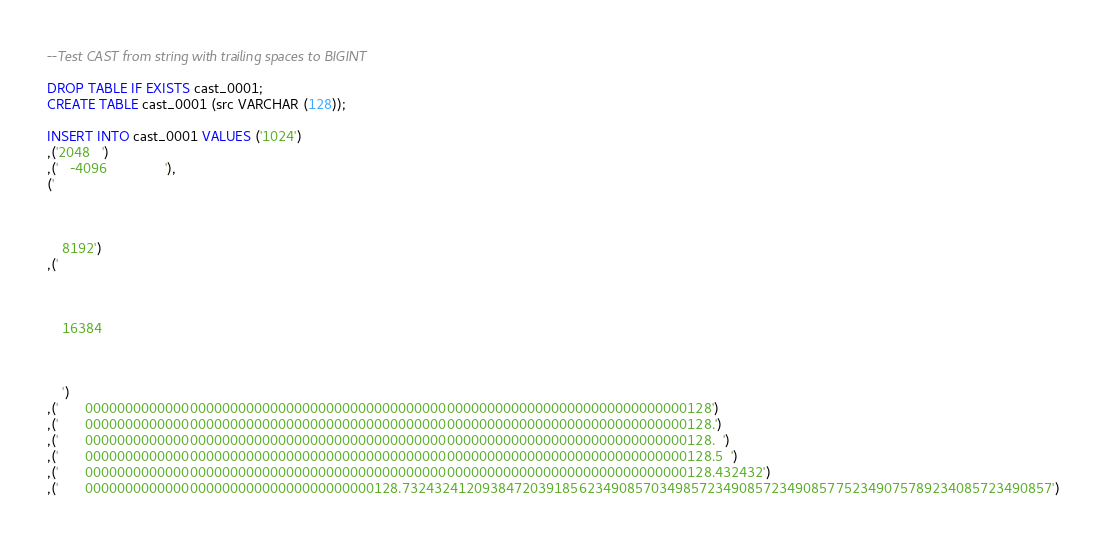Convert code to text. <code><loc_0><loc_0><loc_500><loc_500><_SQL_>--Test CAST from string with trailing spaces to BIGINT

DROP TABLE IF EXISTS cast_0001;
CREATE TABLE cast_0001 (src VARCHAR (128));

INSERT INTO cast_0001 VALUES ('1024')
,('2048   ')
,('   -4096				'),
('

	
	
	8192')
,('
	
	
	
	16384
	
	
	
	')
,('       000000000000000000000000000000000000000000000000000000000000000000000000000128')
,('       000000000000000000000000000000000000000000000000000000000000000000000000000128.')
,('       000000000000000000000000000000000000000000000000000000000000000000000000000128.  ')
,('       000000000000000000000000000000000000000000000000000000000000000000000000000128.5  ')
,('       000000000000000000000000000000000000000000000000000000000000000000000000000128.432432')
,('       000000000000000000000000000000000000128.732432412093847203918562349085703498572349085723490857752349075789234085723490857')</code> 